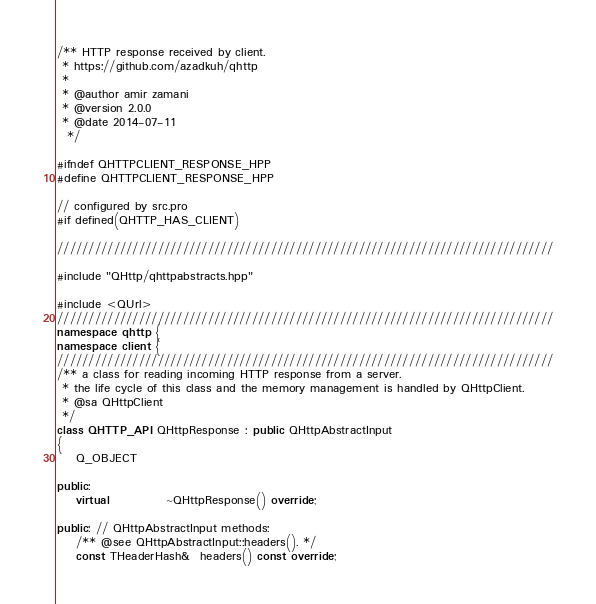<code> <loc_0><loc_0><loc_500><loc_500><_C++_>/** HTTP response received by client.
 * https://github.com/azadkuh/qhttp
 *
 * @author amir zamani
 * @version 2.0.0
 * @date 2014-07-11
  */

#ifndef QHTTPCLIENT_RESPONSE_HPP
#define QHTTPCLIENT_RESPONSE_HPP

// configured by src.pro
#if defined(QHTTP_HAS_CLIENT)

///////////////////////////////////////////////////////////////////////////////

#include "QHttp/qhttpabstracts.hpp"

#include <QUrl>
///////////////////////////////////////////////////////////////////////////////
namespace qhttp {
namespace client {
///////////////////////////////////////////////////////////////////////////////
/** a class for reading incoming HTTP response from a server.
 * the life cycle of this class and the memory management is handled by QHttpClient.
 * @sa QHttpClient
 */
class QHTTP_API QHttpResponse : public QHttpAbstractInput
{
    Q_OBJECT

public:
    virtual            ~QHttpResponse() override;

public: // QHttpAbstractInput methods:
    /** @see QHttpAbstractInput::headers(). */
    const THeaderHash&  headers() const override;
</code> 